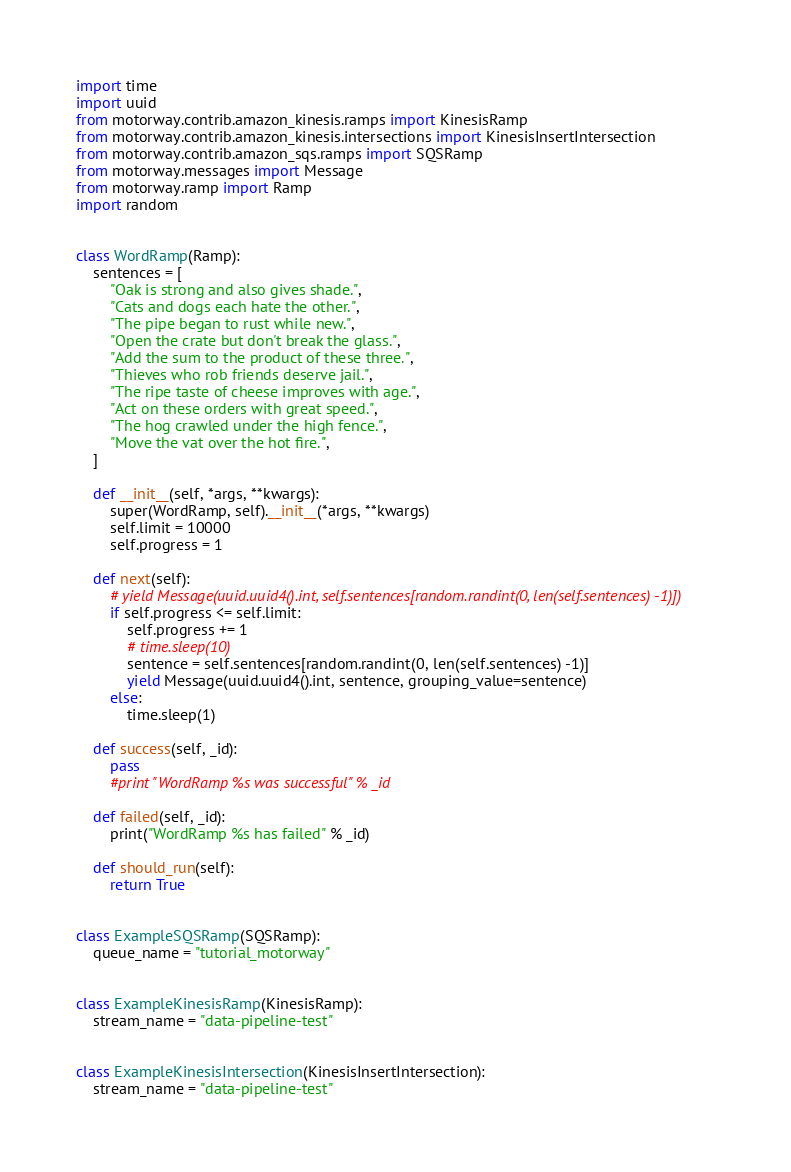<code> <loc_0><loc_0><loc_500><loc_500><_Python_>import time
import uuid
from motorway.contrib.amazon_kinesis.ramps import KinesisRamp
from motorway.contrib.amazon_kinesis.intersections import KinesisInsertIntersection
from motorway.contrib.amazon_sqs.ramps import SQSRamp
from motorway.messages import Message
from motorway.ramp import Ramp
import random


class WordRamp(Ramp):
    sentences = [
        "Oak is strong and also gives shade.",
        "Cats and dogs each hate the other.",
        "The pipe began to rust while new.",
        "Open the crate but don't break the glass.",
        "Add the sum to the product of these three.",
        "Thieves who rob friends deserve jail.",
        "The ripe taste of cheese improves with age.",
        "Act on these orders with great speed.",
        "The hog crawled under the high fence.",
        "Move the vat over the hot fire.",
    ]

    def __init__(self, *args, **kwargs):
        super(WordRamp, self).__init__(*args, **kwargs)
        self.limit = 10000
        self.progress = 1

    def next(self):
        # yield Message(uuid.uuid4().int, self.sentences[random.randint(0, len(self.sentences) -1)])
        if self.progress <= self.limit:
            self.progress += 1
            # time.sleep(10)
            sentence = self.sentences[random.randint(0, len(self.sentences) -1)]
            yield Message(uuid.uuid4().int, sentence, grouping_value=sentence)
        else:
            time.sleep(1)

    def success(self, _id):
        pass
        #print "WordRamp %s was successful" % _id

    def failed(self, _id):
        print("WordRamp %s has failed" % _id)

    def should_run(self):
        return True


class ExampleSQSRamp(SQSRamp):
    queue_name = "tutorial_motorway"


class ExampleKinesisRamp(KinesisRamp):
    stream_name = "data-pipeline-test"


class ExampleKinesisIntersection(KinesisInsertIntersection):
    stream_name = "data-pipeline-test"
</code> 